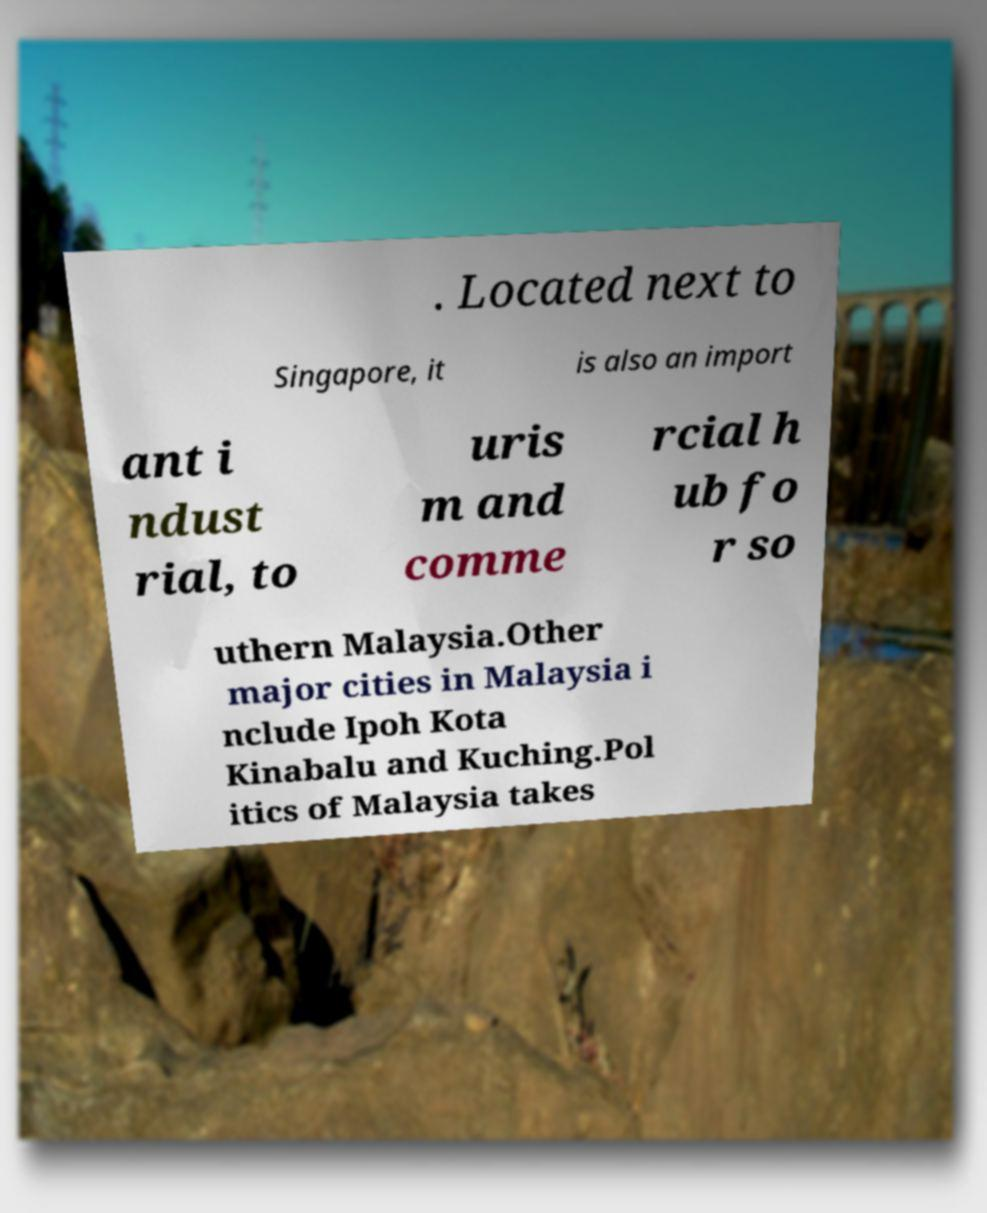Could you assist in decoding the text presented in this image and type it out clearly? . Located next to Singapore, it is also an import ant i ndust rial, to uris m and comme rcial h ub fo r so uthern Malaysia.Other major cities in Malaysia i nclude Ipoh Kota Kinabalu and Kuching.Pol itics of Malaysia takes 